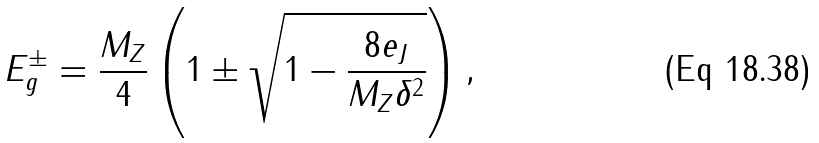Convert formula to latex. <formula><loc_0><loc_0><loc_500><loc_500>E _ { g } ^ { \pm } = \frac { M _ { Z } } { 4 } \left ( 1 \pm \sqrt { 1 - \frac { 8 e _ { J } } { M _ { Z } \delta ^ { 2 } } } \right ) ,</formula> 